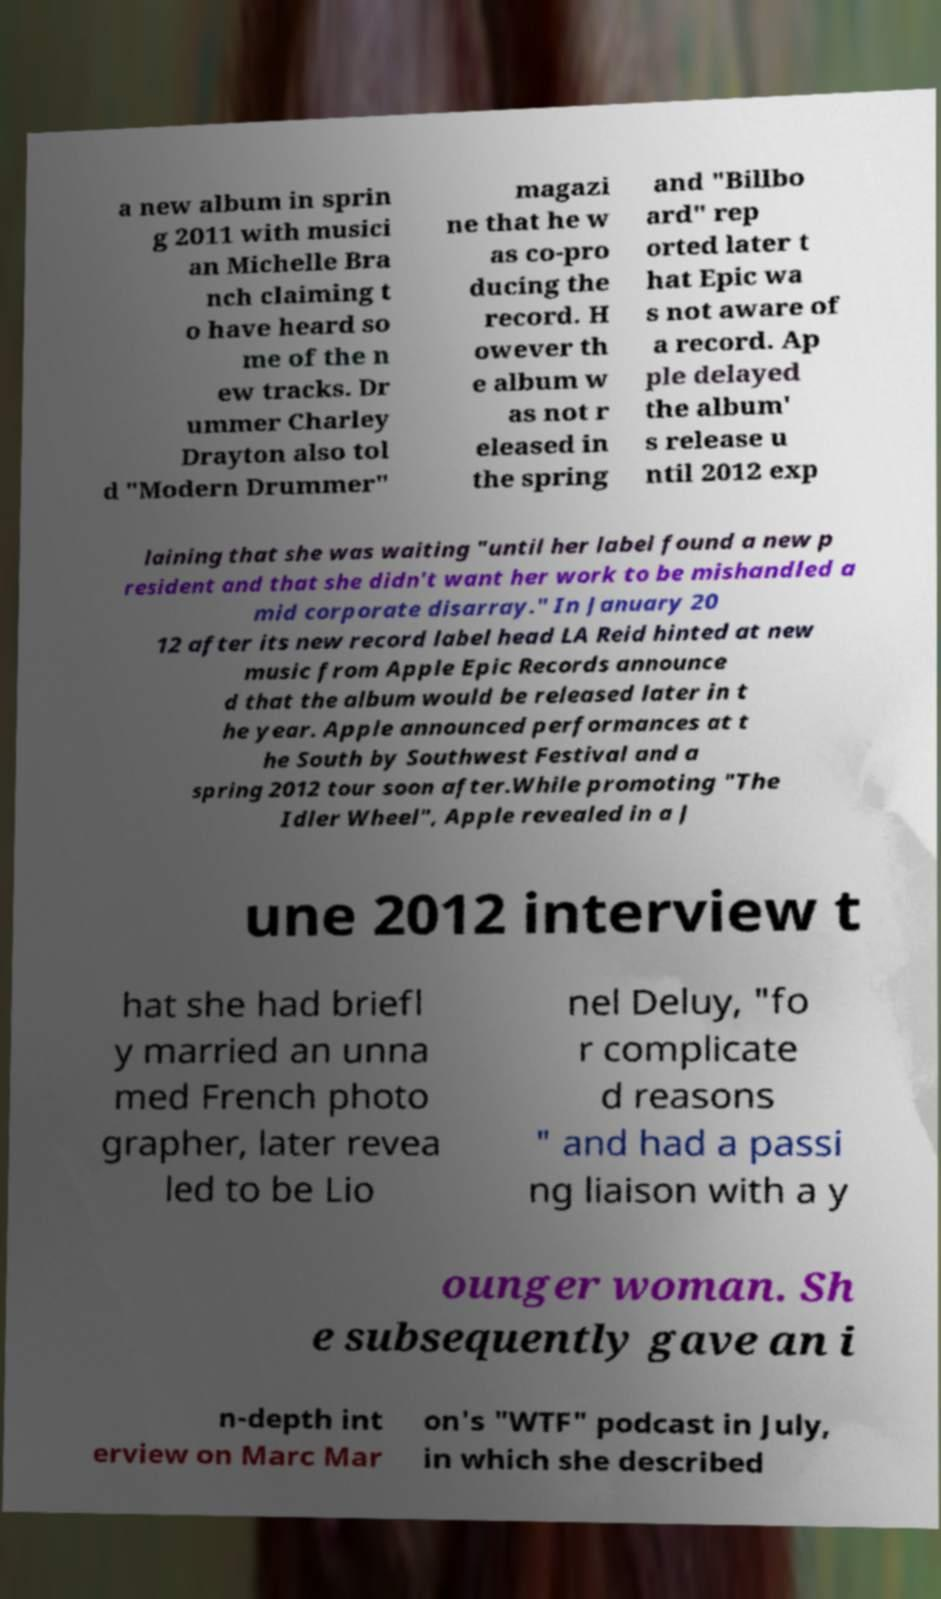For documentation purposes, I need the text within this image transcribed. Could you provide that? a new album in sprin g 2011 with musici an Michelle Bra nch claiming t o have heard so me of the n ew tracks. Dr ummer Charley Drayton also tol d "Modern Drummer" magazi ne that he w as co-pro ducing the record. H owever th e album w as not r eleased in the spring and "Billbo ard" rep orted later t hat Epic wa s not aware of a record. Ap ple delayed the album' s release u ntil 2012 exp laining that she was waiting "until her label found a new p resident and that she didn't want her work to be mishandled a mid corporate disarray." In January 20 12 after its new record label head LA Reid hinted at new music from Apple Epic Records announce d that the album would be released later in t he year. Apple announced performances at t he South by Southwest Festival and a spring 2012 tour soon after.While promoting "The Idler Wheel", Apple revealed in a J une 2012 interview t hat she had briefl y married an unna med French photo grapher, later revea led to be Lio nel Deluy, "fo r complicate d reasons " and had a passi ng liaison with a y ounger woman. Sh e subsequently gave an i n-depth int erview on Marc Mar on's "WTF" podcast in July, in which she described 